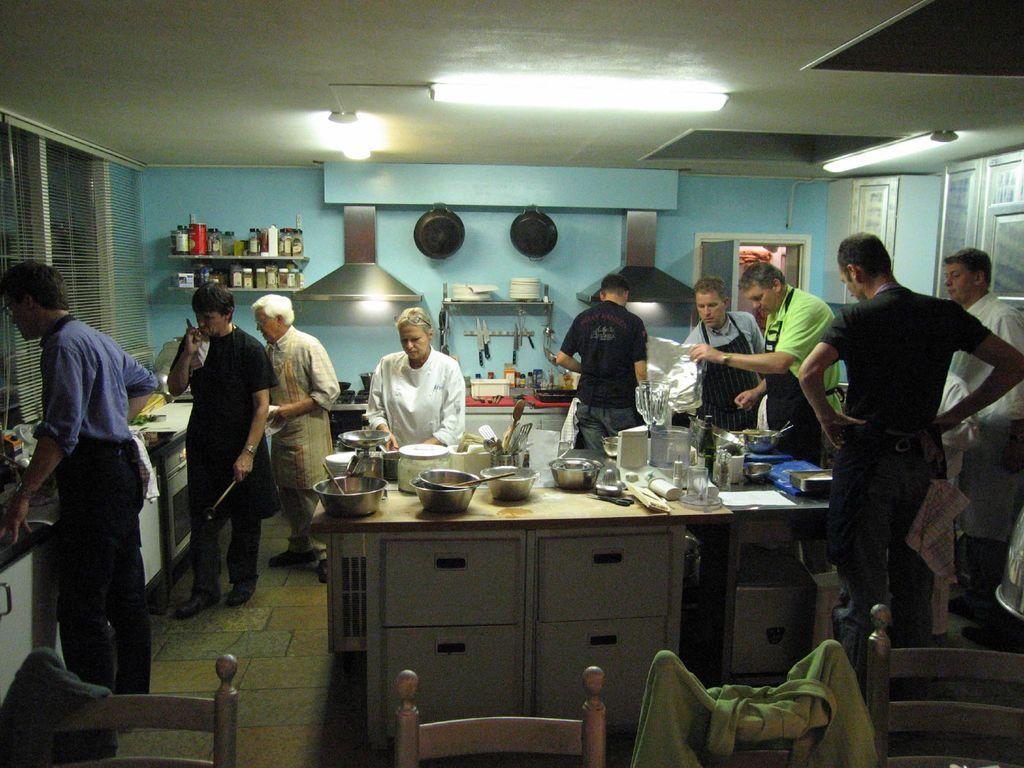In one or two sentences, can you explain what this image depicts? In this image we can see there are people standing on the floor and there are chairs and clothes. And we can see the table with racks, on that there are bowls, bottles, spoons and few objects. At the back we can see the wall with racks in that there are bottles, pan, plates and a few objects. And there are windows and lights. 